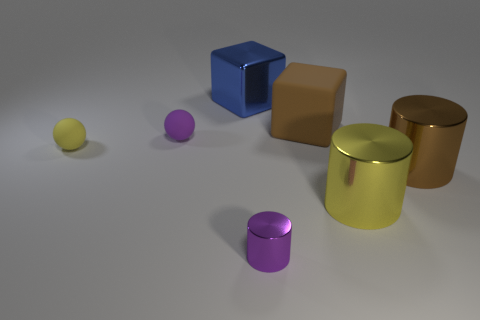Subtract all purple cylinders. How many cylinders are left? 2 Add 3 metal things. How many objects exist? 10 Subtract 1 cylinders. How many cylinders are left? 2 Subtract all large metallic cylinders. Subtract all tiny purple matte things. How many objects are left? 4 Add 1 tiny purple metallic cylinders. How many tiny purple metallic cylinders are left? 2 Add 5 big brown cubes. How many big brown cubes exist? 6 Subtract 0 red cubes. How many objects are left? 7 Subtract all cubes. How many objects are left? 5 Subtract all purple cylinders. Subtract all blue balls. How many cylinders are left? 2 